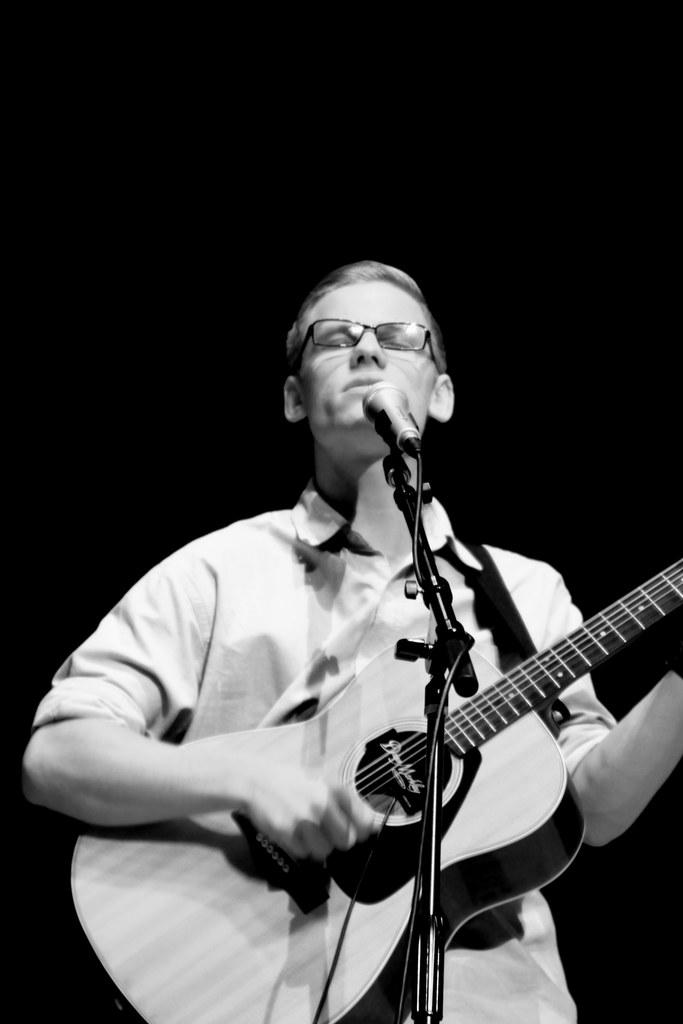What is the man in the image doing? The man in the image is playing a guitar. What object is in front of the man? There is a microphone in front of the man. What type of health insurance does the man have in the image? There is no information about the man's health insurance in the image. How is the distribution of the guitar's sound managed in the image? The image does not provide information about the distribution of the guitar's sound. 